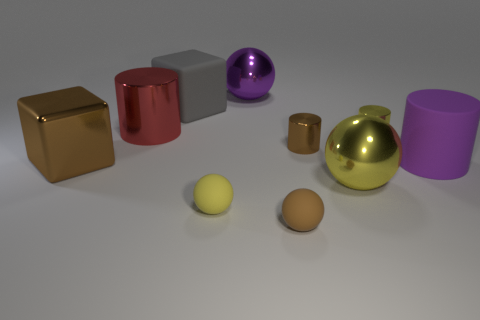Subtract all spheres. How many objects are left? 6 Add 8 yellow cylinders. How many yellow cylinders exist? 9 Subtract 0 cyan balls. How many objects are left? 10 Subtract all rubber blocks. Subtract all big red things. How many objects are left? 8 Add 8 purple shiny objects. How many purple shiny objects are left? 9 